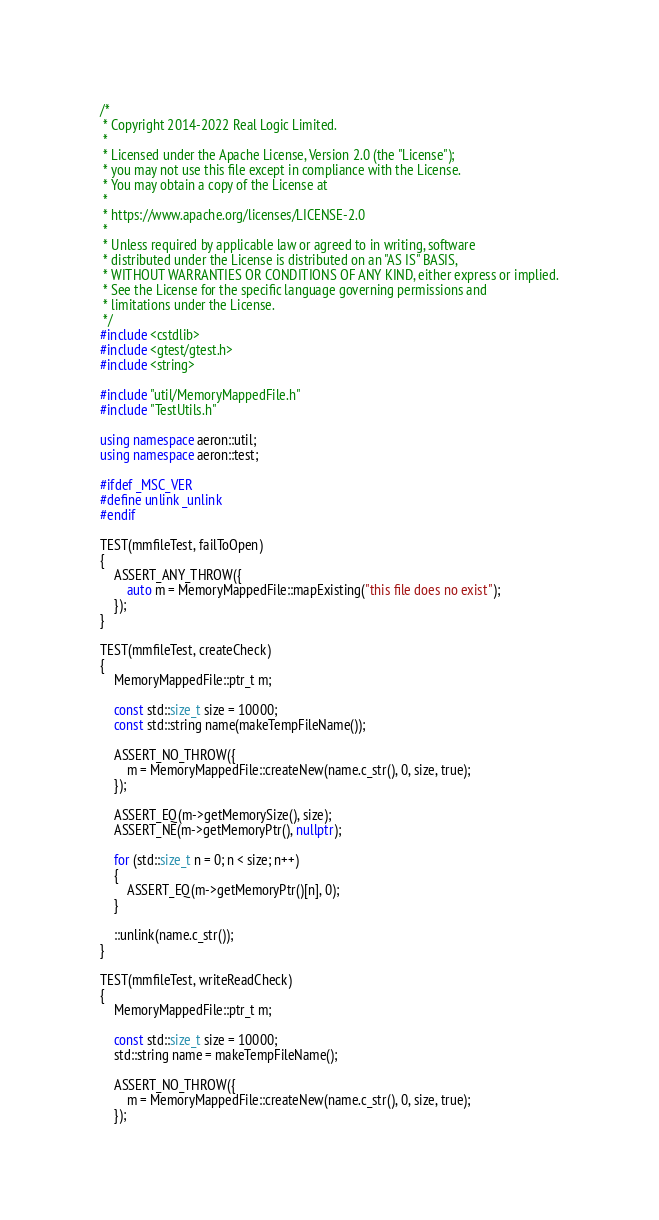<code> <loc_0><loc_0><loc_500><loc_500><_C++_>/*
 * Copyright 2014-2022 Real Logic Limited.
 *
 * Licensed under the Apache License, Version 2.0 (the "License");
 * you may not use this file except in compliance with the License.
 * You may obtain a copy of the License at
 *
 * https://www.apache.org/licenses/LICENSE-2.0
 *
 * Unless required by applicable law or agreed to in writing, software
 * distributed under the License is distributed on an "AS IS" BASIS,
 * WITHOUT WARRANTIES OR CONDITIONS OF ANY KIND, either express or implied.
 * See the License for the specific language governing permissions and
 * limitations under the License.
 */
#include <cstdlib>
#include <gtest/gtest.h>
#include <string>

#include "util/MemoryMappedFile.h"
#include "TestUtils.h"

using namespace aeron::util;
using namespace aeron::test;

#ifdef _MSC_VER
#define unlink _unlink
#endif

TEST(mmfileTest, failToOpen)
{
    ASSERT_ANY_THROW({
        auto m = MemoryMappedFile::mapExisting("this file does no exist");
    });
}

TEST(mmfileTest, createCheck)
{
    MemoryMappedFile::ptr_t m;

    const std::size_t size = 10000;
    const std::string name(makeTempFileName());

    ASSERT_NO_THROW({
        m = MemoryMappedFile::createNew(name.c_str(), 0, size, true);
    });

    ASSERT_EQ(m->getMemorySize(), size);
    ASSERT_NE(m->getMemoryPtr(), nullptr);

    for (std::size_t n = 0; n < size; n++)
    {
        ASSERT_EQ(m->getMemoryPtr()[n], 0);
    }

    ::unlink(name.c_str());
}

TEST(mmfileTest, writeReadCheck)
{
    MemoryMappedFile::ptr_t m;

    const std::size_t size = 10000;
    std::string name = makeTempFileName();

    ASSERT_NO_THROW({
        m = MemoryMappedFile::createNew(name.c_str(), 0, size, true);
    });
</code> 